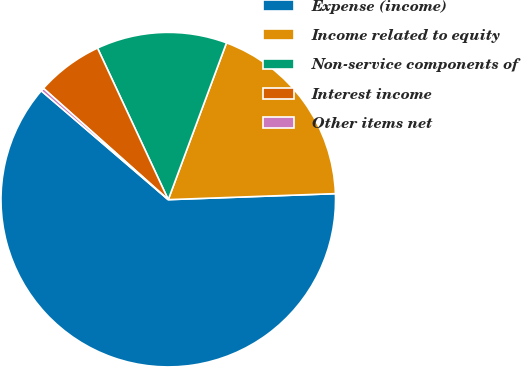Convert chart. <chart><loc_0><loc_0><loc_500><loc_500><pie_chart><fcel>Expense (income)<fcel>Income related to equity<fcel>Non-service components of<fcel>Interest income<fcel>Other items net<nl><fcel>61.85%<fcel>18.77%<fcel>12.61%<fcel>6.46%<fcel>0.31%<nl></chart> 